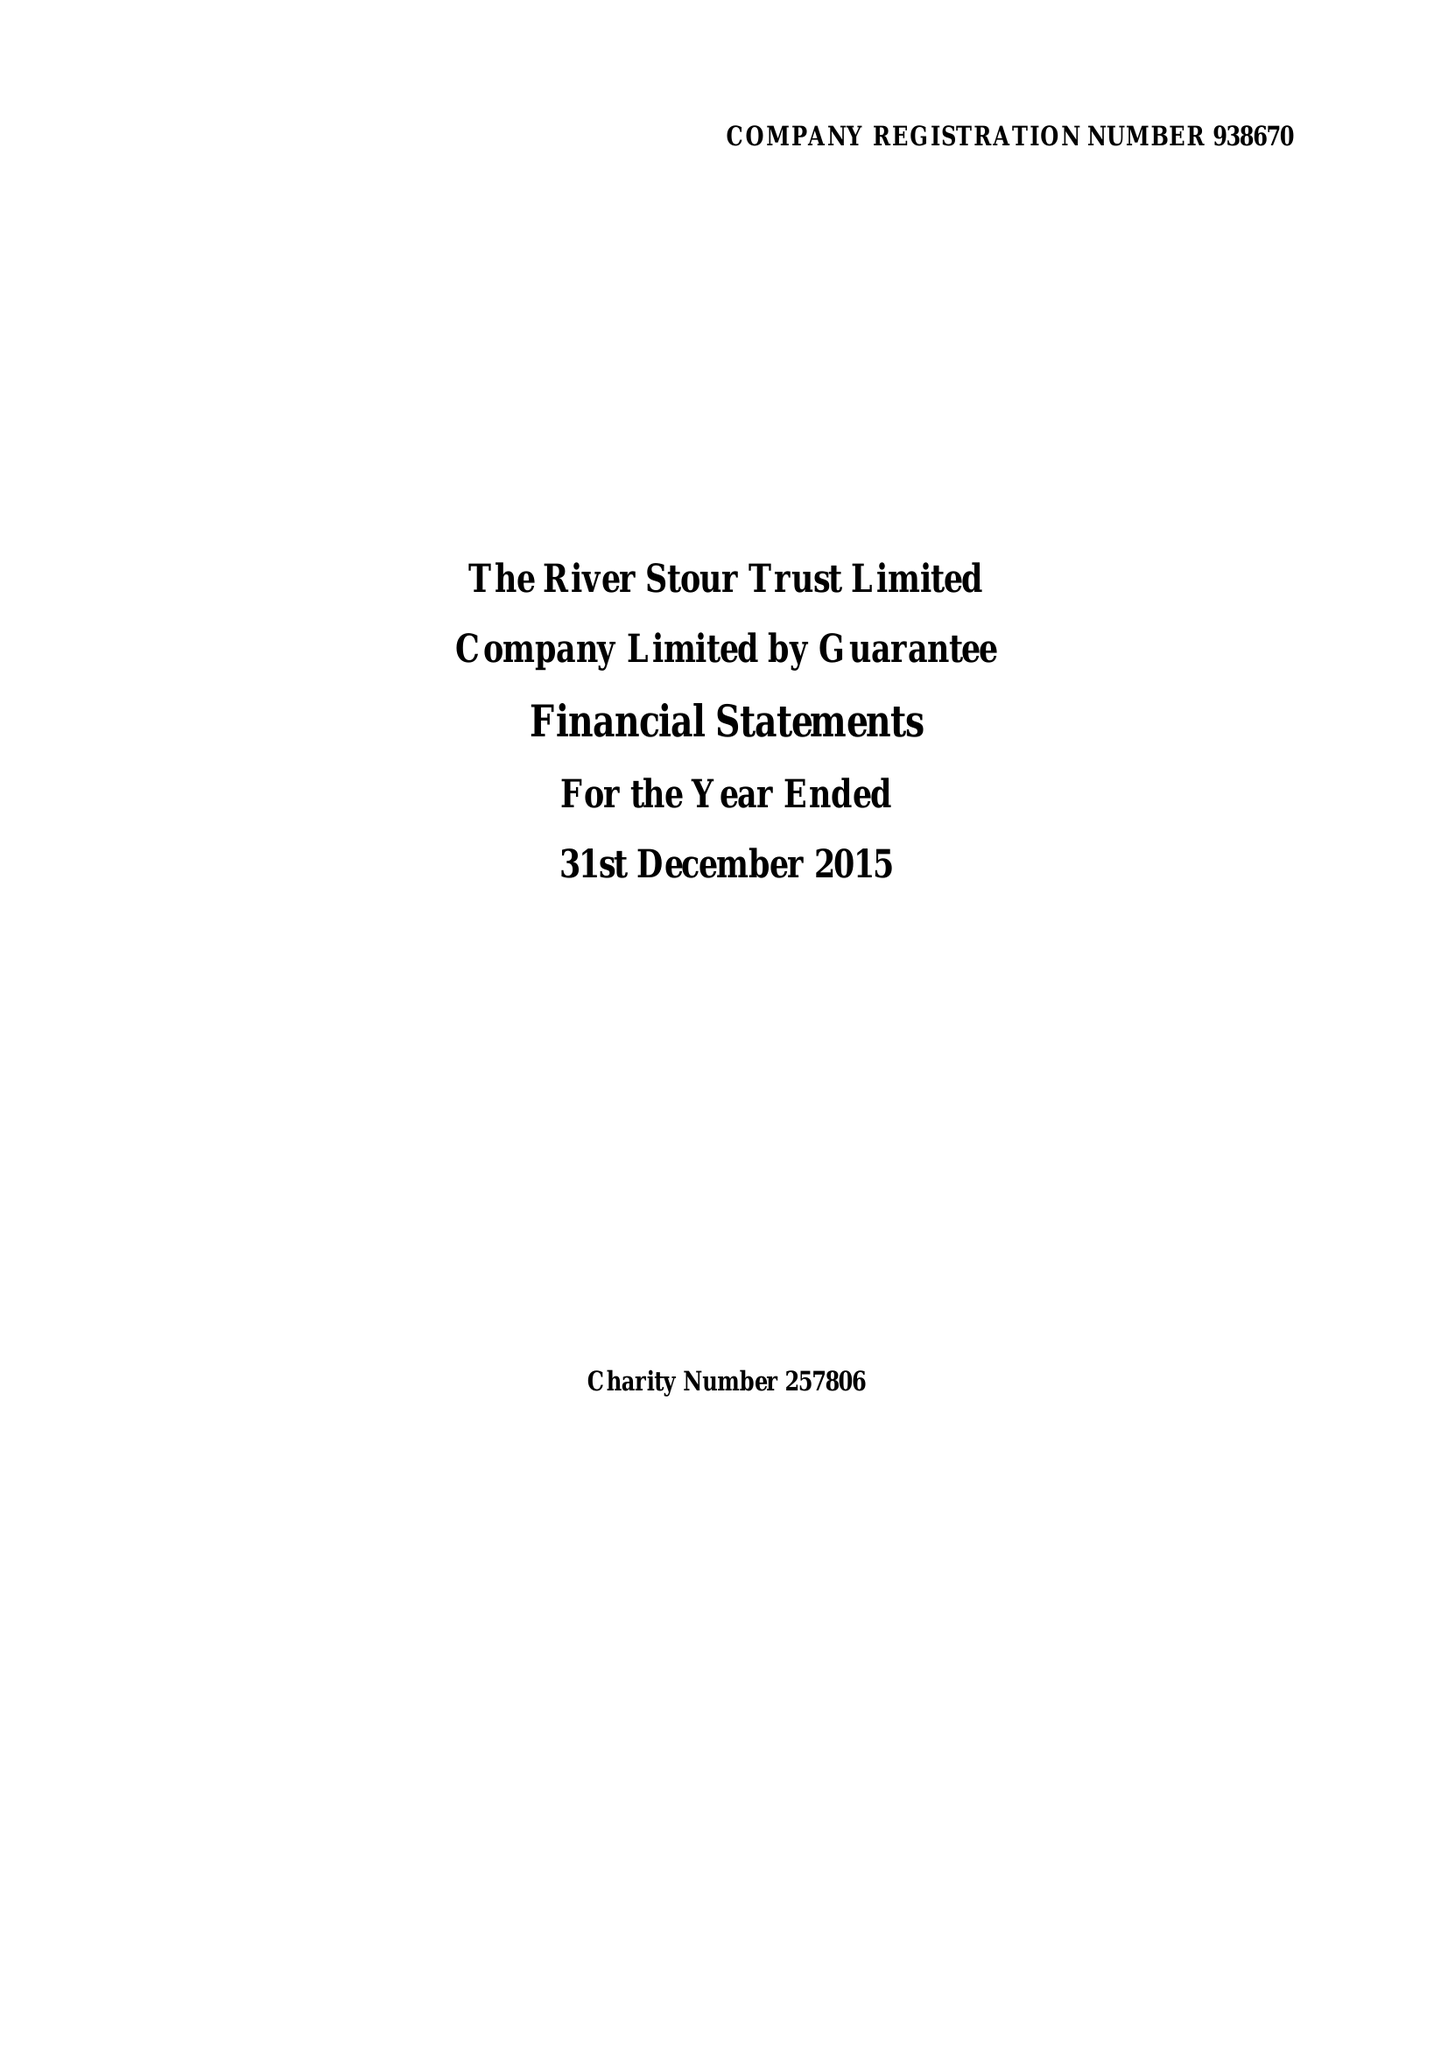What is the value for the report_date?
Answer the question using a single word or phrase. 2015-12-31 